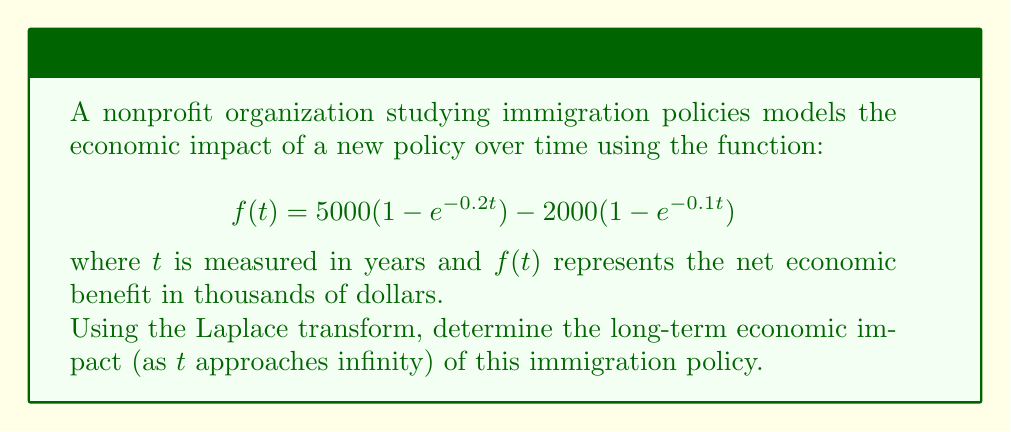Help me with this question. To solve this problem, we'll follow these steps:

1) First, let's recall the Laplace transform of $f(t) = 1 - e^{-at}$:

   $$\mathcal{L}\{1 - e^{-at}\} = \frac{1}{s} - \frac{1}{s+a} = \frac{a}{s(s+a)}$$

2) Now, let's apply the Laplace transform to our function:

   $$\mathcal{L}\{f(t)\} = 5000 \cdot \mathcal{L}\{1 - e^{-0.2t}\} - 2000 \cdot \mathcal{L}\{1 - e^{-0.1t}\}$$

3) Substituting the known transform:

   $$\mathcal{L}\{f(t)\} = 5000 \cdot \frac{0.2}{s(s+0.2)} - 2000 \cdot \frac{0.1}{s(s+0.1)}$$

4) To find the long-term impact, we need to use the Final Value Theorem:

   $$\lim_{t \to \infty} f(t) = \lim_{s \to 0} s \cdot F(s)$$

   where $F(s)$ is the Laplace transform of $f(t)$.

5) Applying this theorem:

   $$\lim_{t \to \infty} f(t) = \lim_{s \to 0} s \cdot \left(5000 \cdot \frac{0.2}{s(s+0.2)} - 2000 \cdot \frac{0.1}{s(s+0.1)}\right)$$

6) Simplifying:

   $$= \lim_{s \to 0} \left(\frac{1000}{s+0.2} - \frac{200}{s+0.1}\right)$$

7) Taking the limit:

   $$= 1000 - 200 = 800$$

Therefore, the long-term economic impact is 800 thousand dollars, or $800,000.
Answer: $800,000 